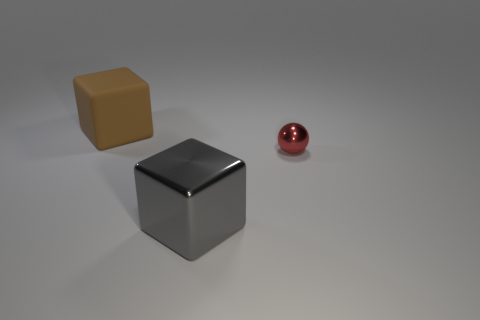Which object in the image is the smallest? The smallest object in the image is the red, glossy sphere. 